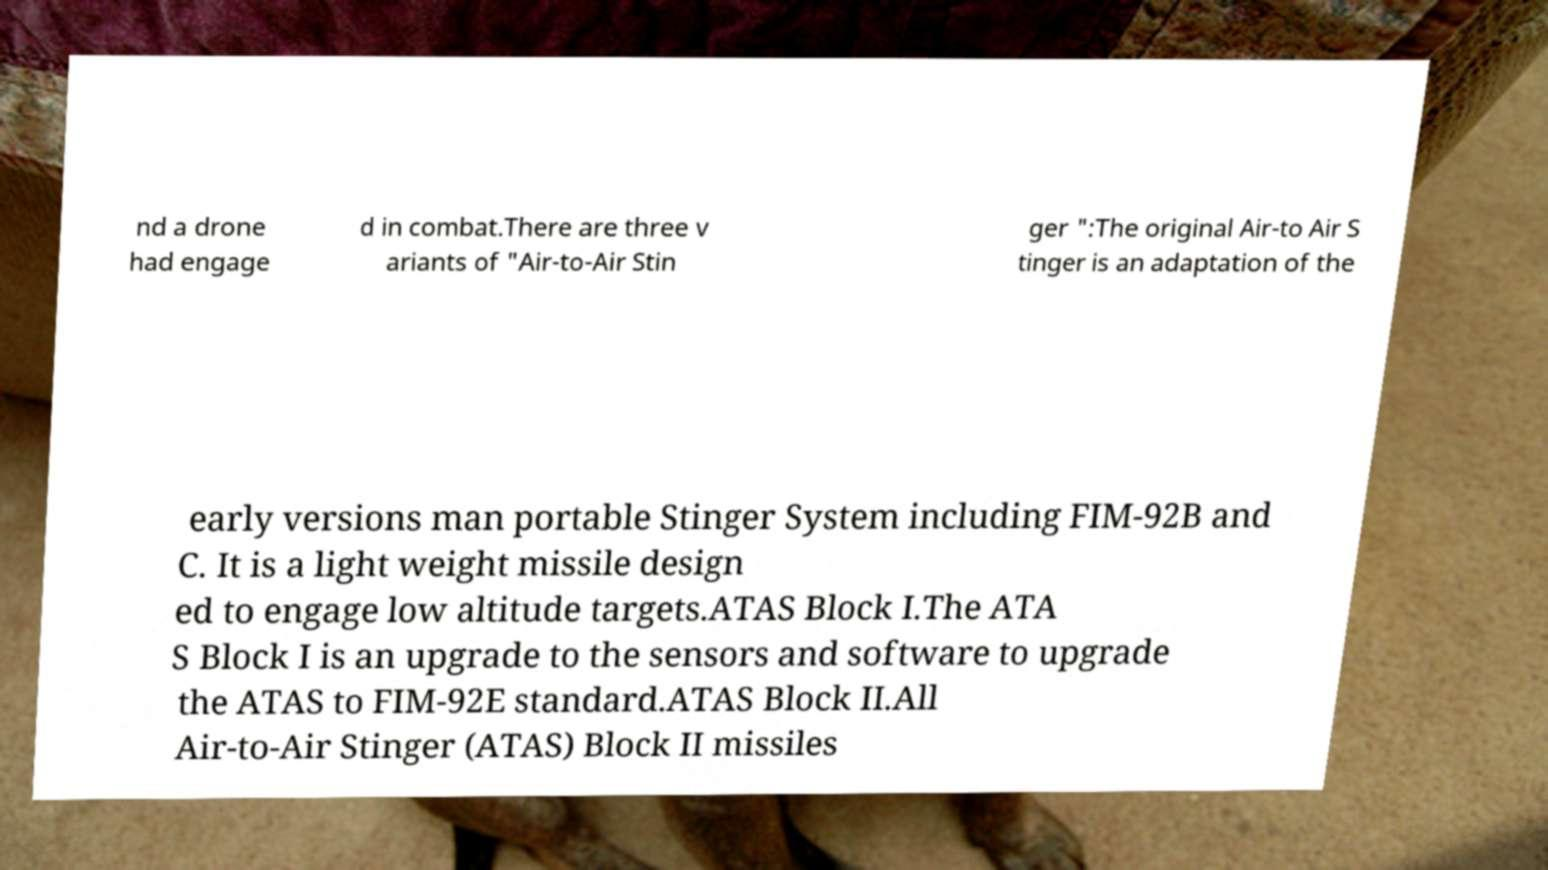For documentation purposes, I need the text within this image transcribed. Could you provide that? nd a drone had engage d in combat.There are three v ariants of "Air-to-Air Stin ger ":The original Air-to Air S tinger is an adaptation of the early versions man portable Stinger System including FIM-92B and C. It is a light weight missile design ed to engage low altitude targets.ATAS Block I.The ATA S Block I is an upgrade to the sensors and software to upgrade the ATAS to FIM-92E standard.ATAS Block II.All Air-to-Air Stinger (ATAS) Block II missiles 